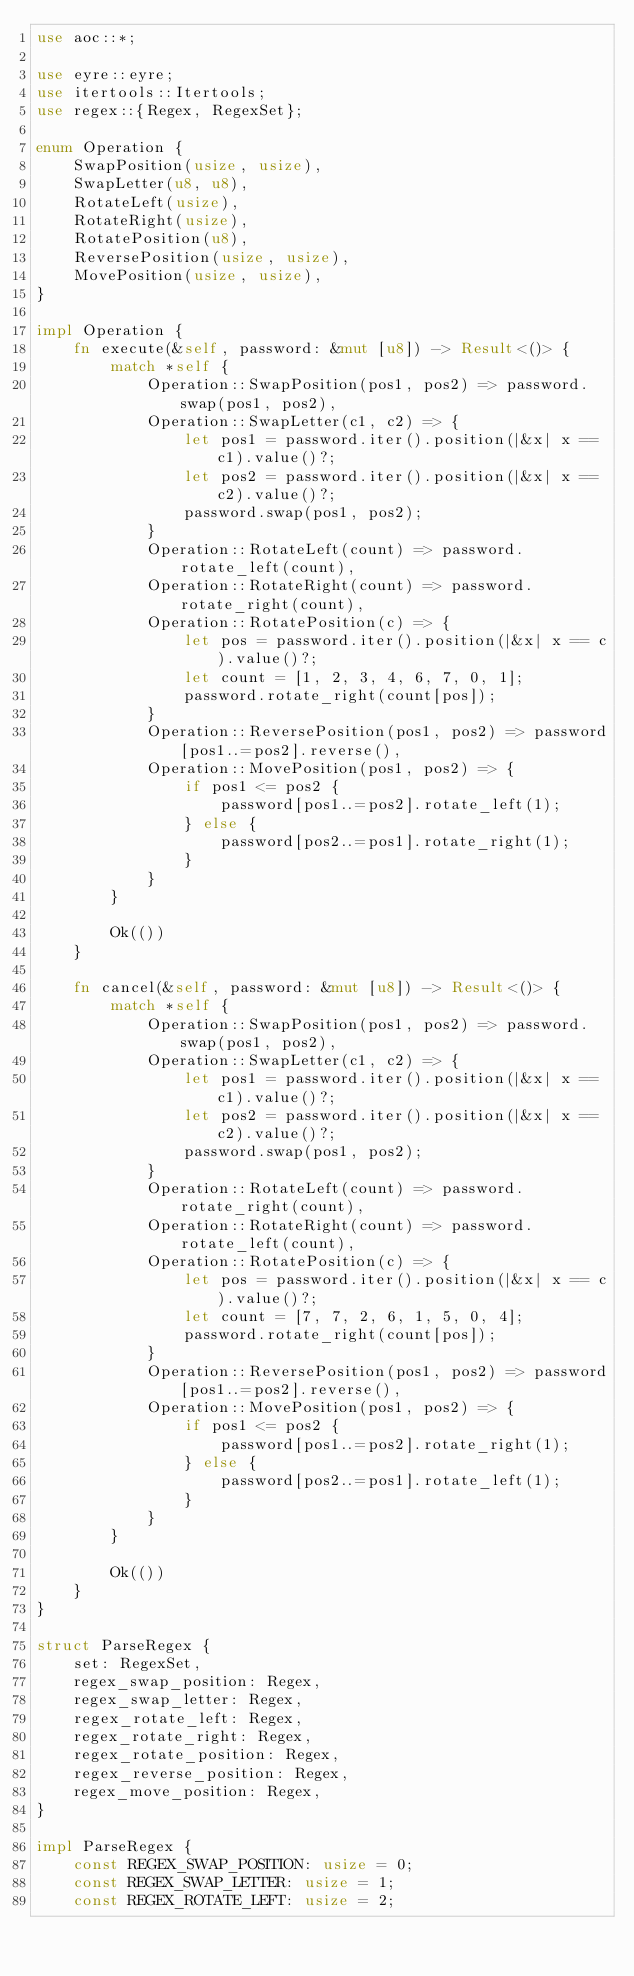<code> <loc_0><loc_0><loc_500><loc_500><_Rust_>use aoc::*;

use eyre::eyre;
use itertools::Itertools;
use regex::{Regex, RegexSet};

enum Operation {
    SwapPosition(usize, usize),
    SwapLetter(u8, u8),
    RotateLeft(usize),
    RotateRight(usize),
    RotatePosition(u8),
    ReversePosition(usize, usize),
    MovePosition(usize, usize),
}

impl Operation {
    fn execute(&self, password: &mut [u8]) -> Result<()> {
        match *self {
            Operation::SwapPosition(pos1, pos2) => password.swap(pos1, pos2),
            Operation::SwapLetter(c1, c2) => {
                let pos1 = password.iter().position(|&x| x == c1).value()?;
                let pos2 = password.iter().position(|&x| x == c2).value()?;
                password.swap(pos1, pos2);
            }
            Operation::RotateLeft(count) => password.rotate_left(count),
            Operation::RotateRight(count) => password.rotate_right(count),
            Operation::RotatePosition(c) => {
                let pos = password.iter().position(|&x| x == c).value()?;
                let count = [1, 2, 3, 4, 6, 7, 0, 1];
                password.rotate_right(count[pos]);
            }
            Operation::ReversePosition(pos1, pos2) => password[pos1..=pos2].reverse(),
            Operation::MovePosition(pos1, pos2) => {
                if pos1 <= pos2 {
                    password[pos1..=pos2].rotate_left(1);
                } else {
                    password[pos2..=pos1].rotate_right(1);
                }
            }
        }

        Ok(())
    }

    fn cancel(&self, password: &mut [u8]) -> Result<()> {
        match *self {
            Operation::SwapPosition(pos1, pos2) => password.swap(pos1, pos2),
            Operation::SwapLetter(c1, c2) => {
                let pos1 = password.iter().position(|&x| x == c1).value()?;
                let pos2 = password.iter().position(|&x| x == c2).value()?;
                password.swap(pos1, pos2);
            }
            Operation::RotateLeft(count) => password.rotate_right(count),
            Operation::RotateRight(count) => password.rotate_left(count),
            Operation::RotatePosition(c) => {
                let pos = password.iter().position(|&x| x == c).value()?;
                let count = [7, 7, 2, 6, 1, 5, 0, 4];
                password.rotate_right(count[pos]);
            }
            Operation::ReversePosition(pos1, pos2) => password[pos1..=pos2].reverse(),
            Operation::MovePosition(pos1, pos2) => {
                if pos1 <= pos2 {
                    password[pos1..=pos2].rotate_right(1);
                } else {
                    password[pos2..=pos1].rotate_left(1);
                }
            }
        }

        Ok(())
    }
}

struct ParseRegex {
    set: RegexSet,
    regex_swap_position: Regex,
    regex_swap_letter: Regex,
    regex_rotate_left: Regex,
    regex_rotate_right: Regex,
    regex_rotate_position: Regex,
    regex_reverse_position: Regex,
    regex_move_position: Regex,
}

impl ParseRegex {
    const REGEX_SWAP_POSITION: usize = 0;
    const REGEX_SWAP_LETTER: usize = 1;
    const REGEX_ROTATE_LEFT: usize = 2;</code> 